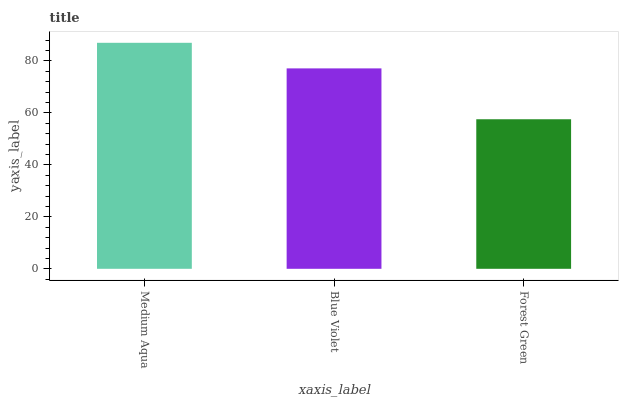Is Forest Green the minimum?
Answer yes or no. Yes. Is Medium Aqua the maximum?
Answer yes or no. Yes. Is Blue Violet the minimum?
Answer yes or no. No. Is Blue Violet the maximum?
Answer yes or no. No. Is Medium Aqua greater than Blue Violet?
Answer yes or no. Yes. Is Blue Violet less than Medium Aqua?
Answer yes or no. Yes. Is Blue Violet greater than Medium Aqua?
Answer yes or no. No. Is Medium Aqua less than Blue Violet?
Answer yes or no. No. Is Blue Violet the high median?
Answer yes or no. Yes. Is Blue Violet the low median?
Answer yes or no. Yes. Is Medium Aqua the high median?
Answer yes or no. No. Is Forest Green the low median?
Answer yes or no. No. 